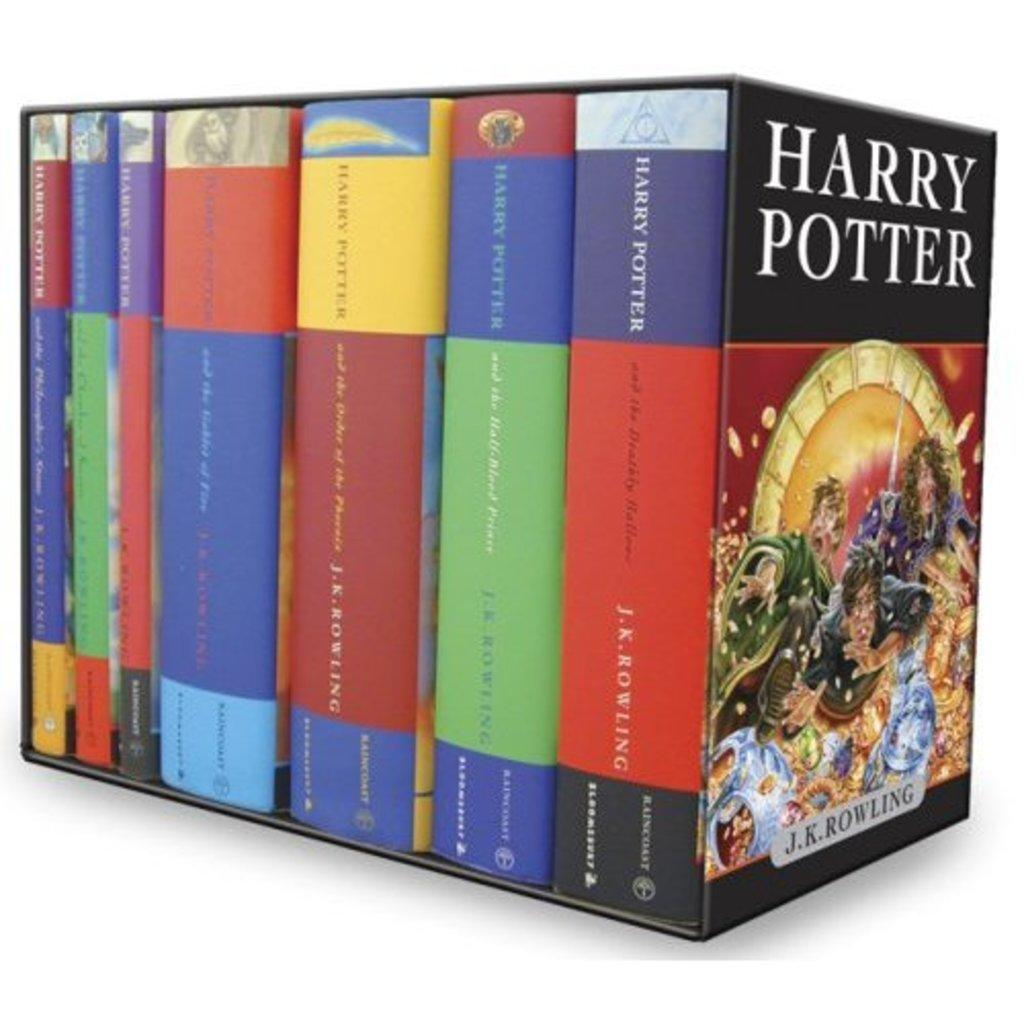Provide a one-sentence caption for the provided image. A case set of the Harry potter books in various colors. 